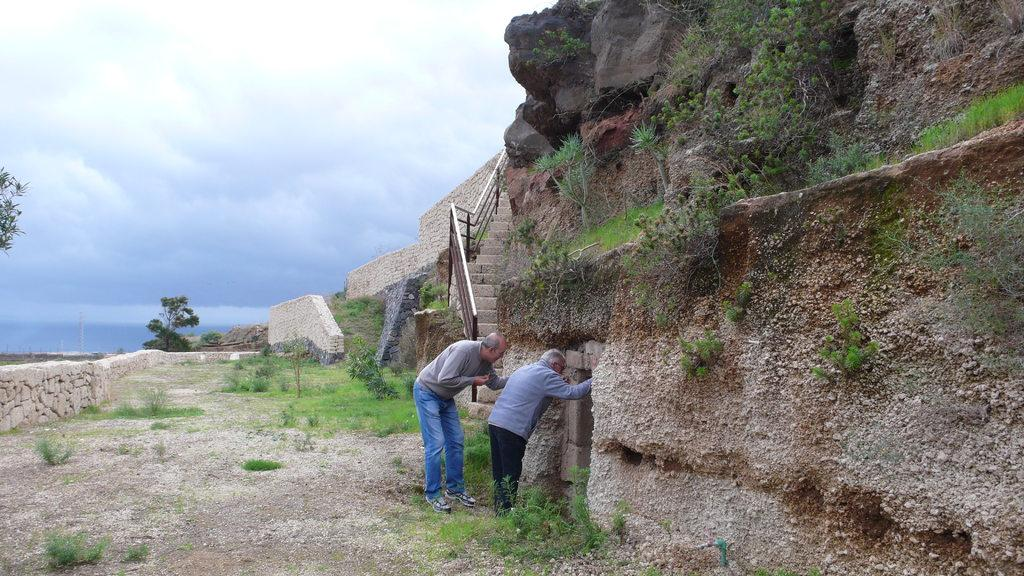What type of natural elements can be seen in the image? There are rocks, grass, plants, and trees in the image. What architectural features are present in the image? There are stairs, a wall, and a fence in the image. What is visible at the top of the image? The sky is visible at the top of the image. Can you tell me how many family members are visible in the image? There are no family members present in the image. What type of vessel is being used to burst the rocks in the image? There is no vessel or bursting of rocks depicted in the image. 